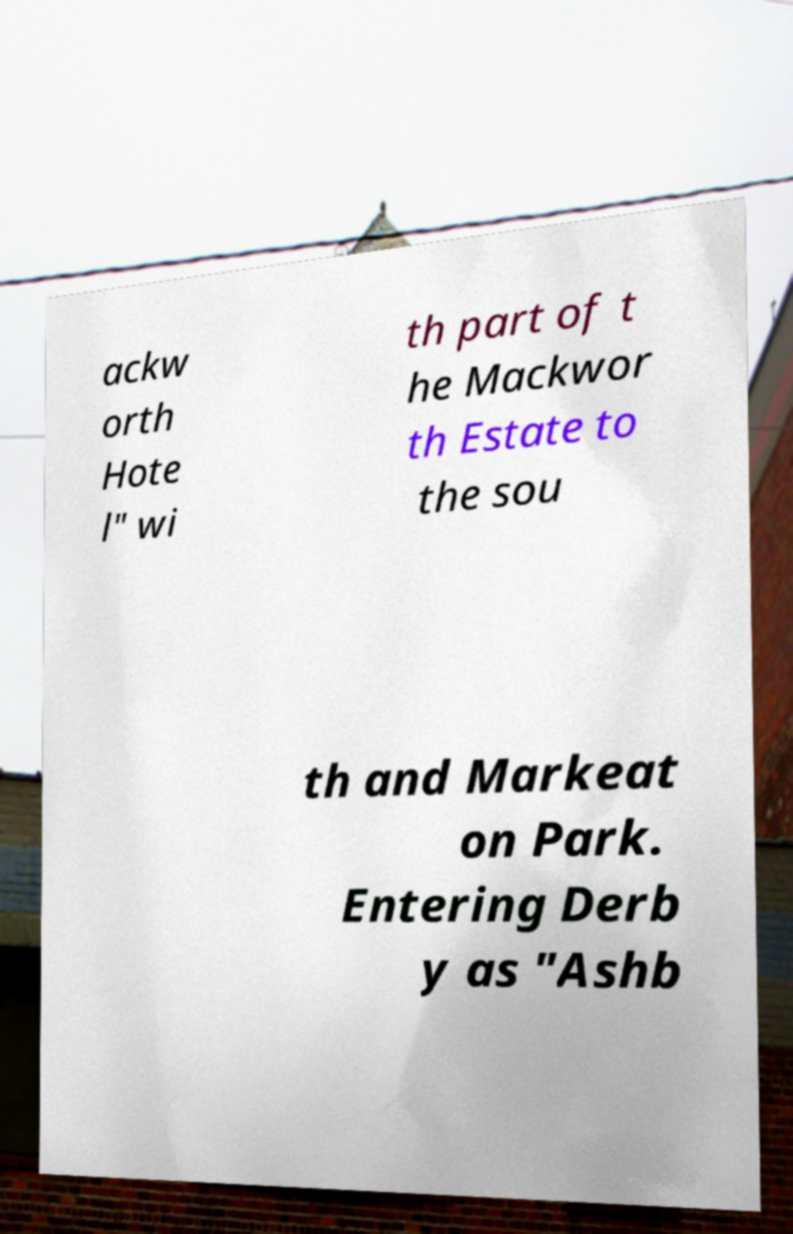There's text embedded in this image that I need extracted. Can you transcribe it verbatim? ackw orth Hote l" wi th part of t he Mackwor th Estate to the sou th and Markeat on Park. Entering Derb y as "Ashb 